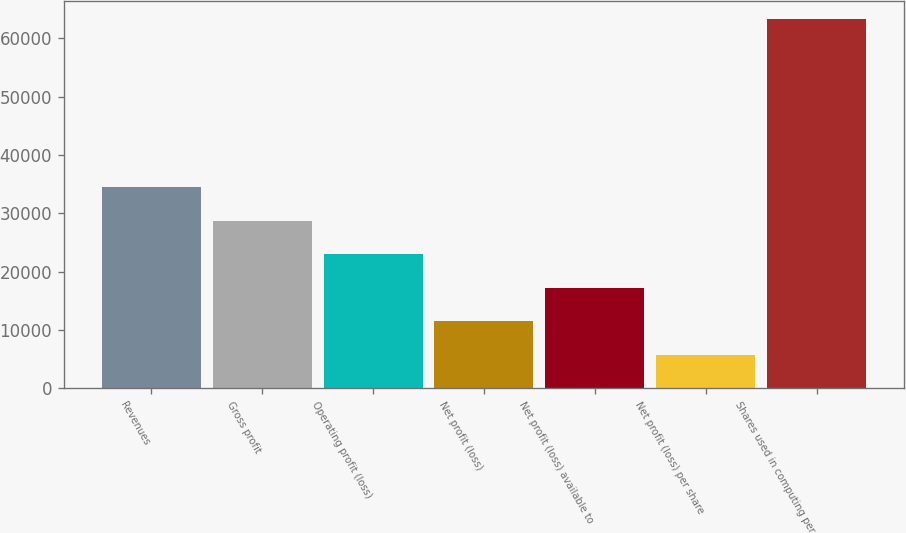<chart> <loc_0><loc_0><loc_500><loc_500><bar_chart><fcel>Revenues<fcel>Gross profit<fcel>Operating profit (loss)<fcel>Net profit (loss)<fcel>Net profit (loss) available to<fcel>Net profit (loss) per share<fcel>Shares used in computing per<nl><fcel>34493.5<fcel>28744.6<fcel>22995.7<fcel>11497.9<fcel>17246.8<fcel>5749.02<fcel>63237.9<nl></chart> 